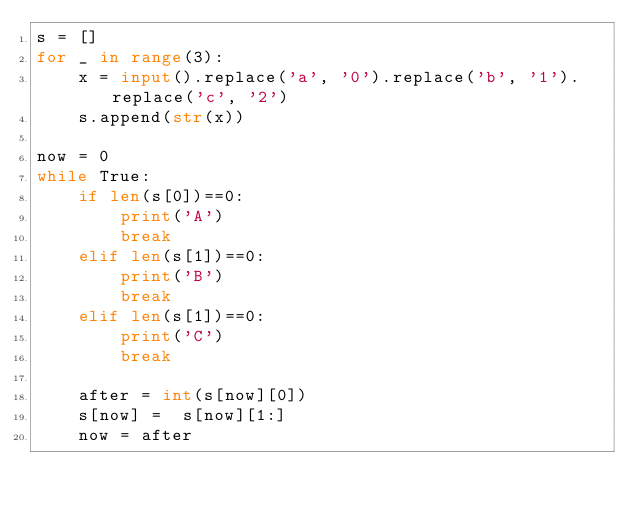<code> <loc_0><loc_0><loc_500><loc_500><_Python_>s = []
for _ in range(3):
    x = input().replace('a', '0').replace('b', '1').replace('c', '2')
    s.append(str(x))
    
now = 0
while True:
    if len(s[0])==0:
        print('A')
        break
    elif len(s[1])==0:
        print('B')
        break
    elif len(s[1])==0:
        print('C')
        break
        
    after = int(s[now][0])
    s[now] =  s[now][1:]
    now = after
    </code> 